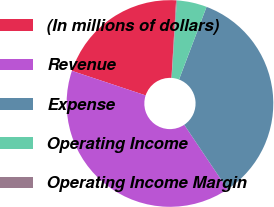Convert chart. <chart><loc_0><loc_0><loc_500><loc_500><pie_chart><fcel>(In millions of dollars)<fcel>Revenue<fcel>Expense<fcel>Operating Income<fcel>Operating Income Margin<nl><fcel>20.84%<fcel>39.52%<fcel>34.83%<fcel>4.69%<fcel>0.12%<nl></chart> 